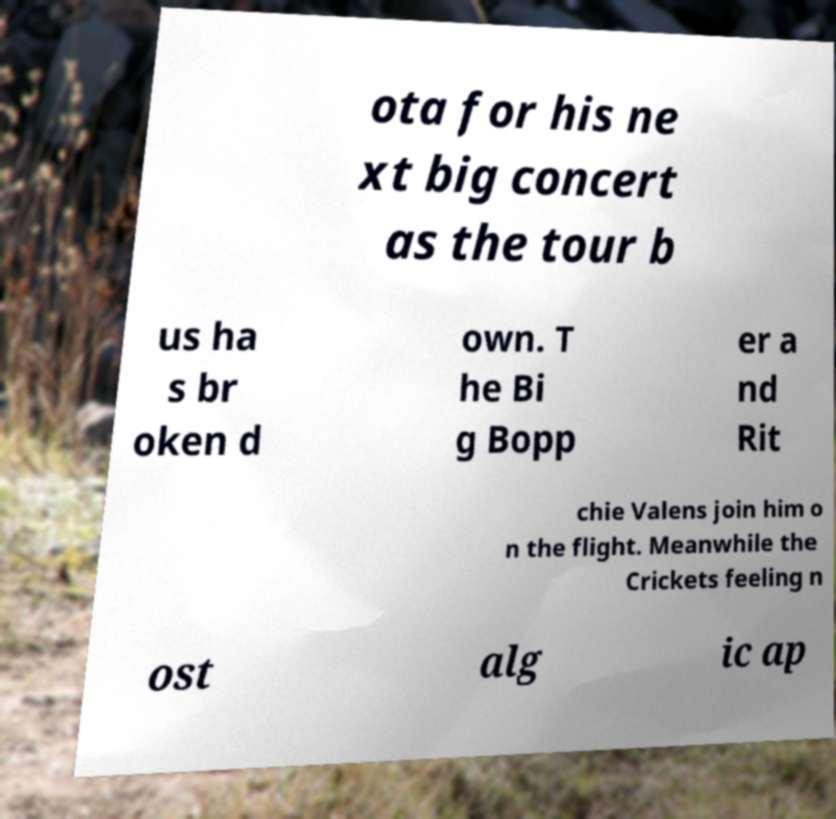Can you read and provide the text displayed in the image?This photo seems to have some interesting text. Can you extract and type it out for me? ota for his ne xt big concert as the tour b us ha s br oken d own. T he Bi g Bopp er a nd Rit chie Valens join him o n the flight. Meanwhile the Crickets feeling n ost alg ic ap 